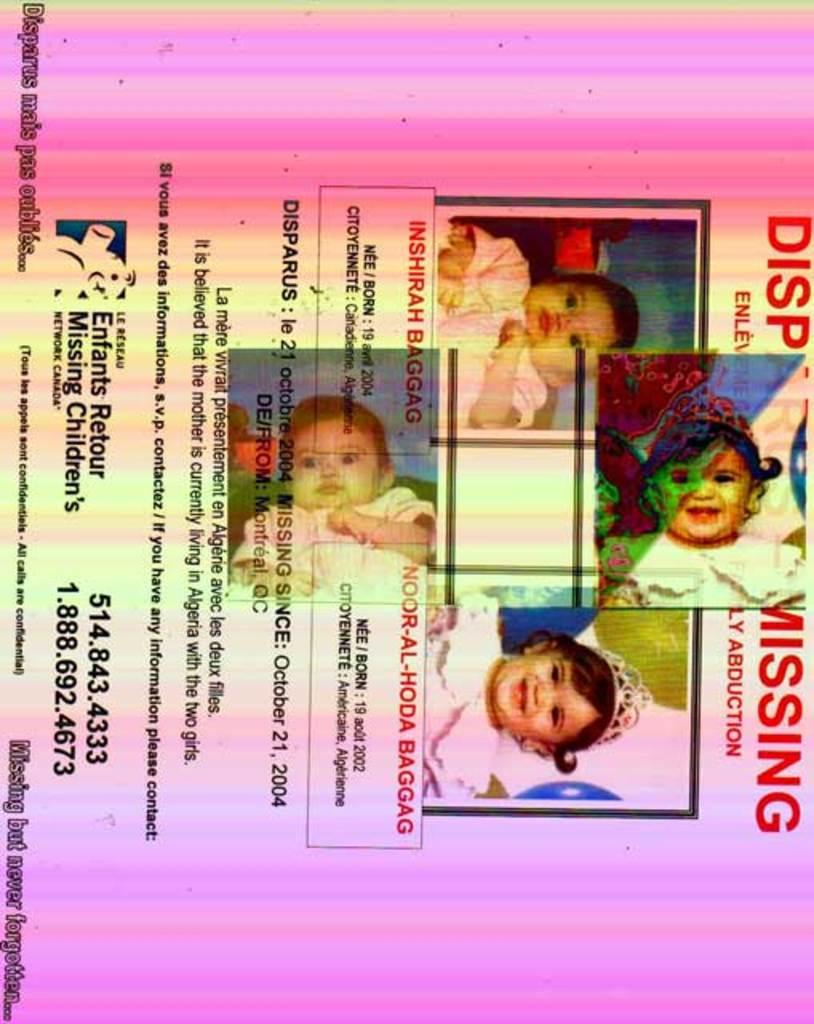What is the main subject of the poster in the image? The poster contains information about four missing children. What type of information is provided on the poster? The poster provides information about four missing children. What effect does the sea have on the authority of the poster in the image? The image does not show any sea or any indication of its effect on the poster's authority. 